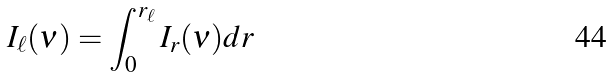Convert formula to latex. <formula><loc_0><loc_0><loc_500><loc_500>I _ { \ell } ( \nu ) = \int _ { 0 } ^ { r _ { \ell } } I _ { r } ( \nu ) d r</formula> 